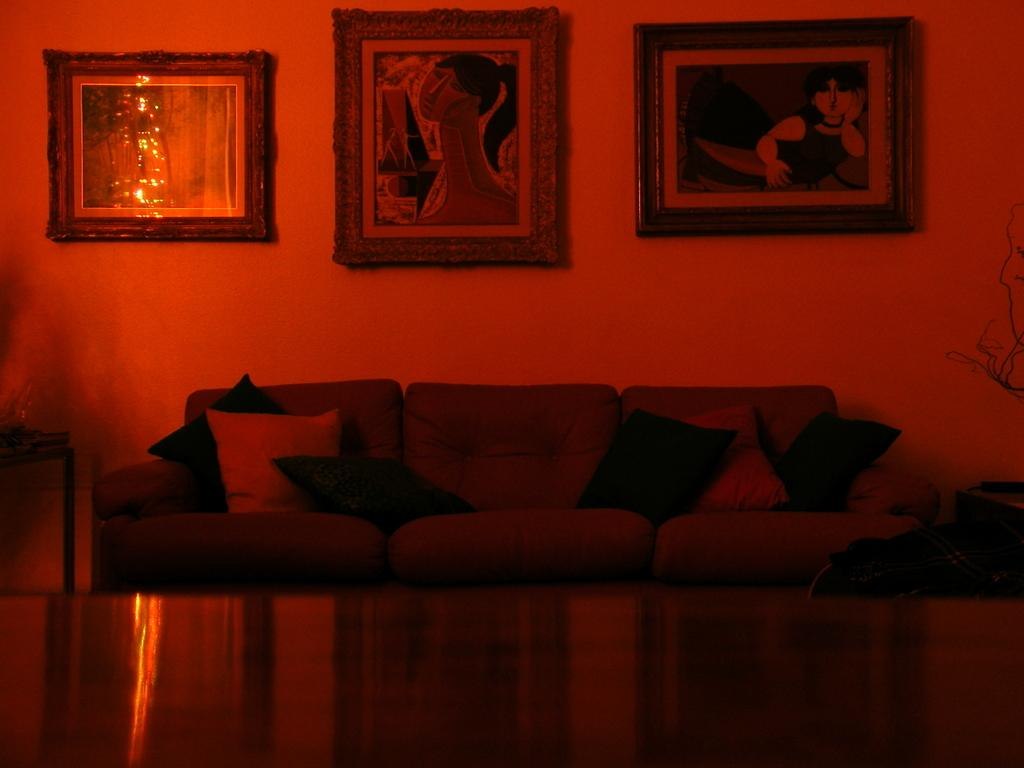What type of furniture is in the image? There is a couch in the image. What is on the couch? The couch has pillows on it. What can be seen on the wall in the image? There are photo frames on the wall. What type of rail is present in the image? There is no rail present in the image. How does the flesh appear in the image? There is no flesh visible in the image. 